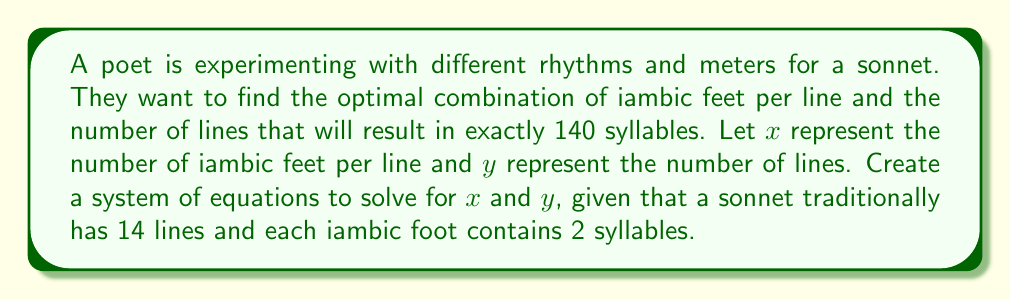Could you help me with this problem? Let's break this down step-by-step:

1) First, we need to understand what the variables represent:
   $x$ = number of iambic feet per line
   $y$ = number of lines

2) We know that each iambic foot contains 2 syllables. So, the total number of syllables in one line is $2x$.

3) The total number of syllables in the entire poem is the number of syllables per line multiplied by the number of lines. This should equal 140:

   $$2xy = 140$$ (Equation 1)

4) We're also told that a sonnet traditionally has 14 lines. While the poet is experimenting, we can use this as our second equation:

   $$y = 14$$ (Equation 2)

5) Now we have a system of two equations with two unknowns:

   $$2xy = 140$$
   $$y = 14$$

6) We can solve this by substitution. Let's substitute $y = 14$ into the first equation:

   $$2x(14) = 140$$

7) Simplify:

   $$28x = 140$$

8) Divide both sides by 28:

   $$x = 5$$

9) So, we've found that $x = 5$ and $y = 14$.

10) To verify, let's plug these values back into our original equation:
    
    $$2(5)(14) = 140$$
    $$140 = 140$$

This confirms our solution is correct.
Answer: The optimal combination is 5 iambic feet per line and 14 lines. In poetic terms, this describes the structure of a traditional English sonnet: 14 lines of iambic pentameter. 